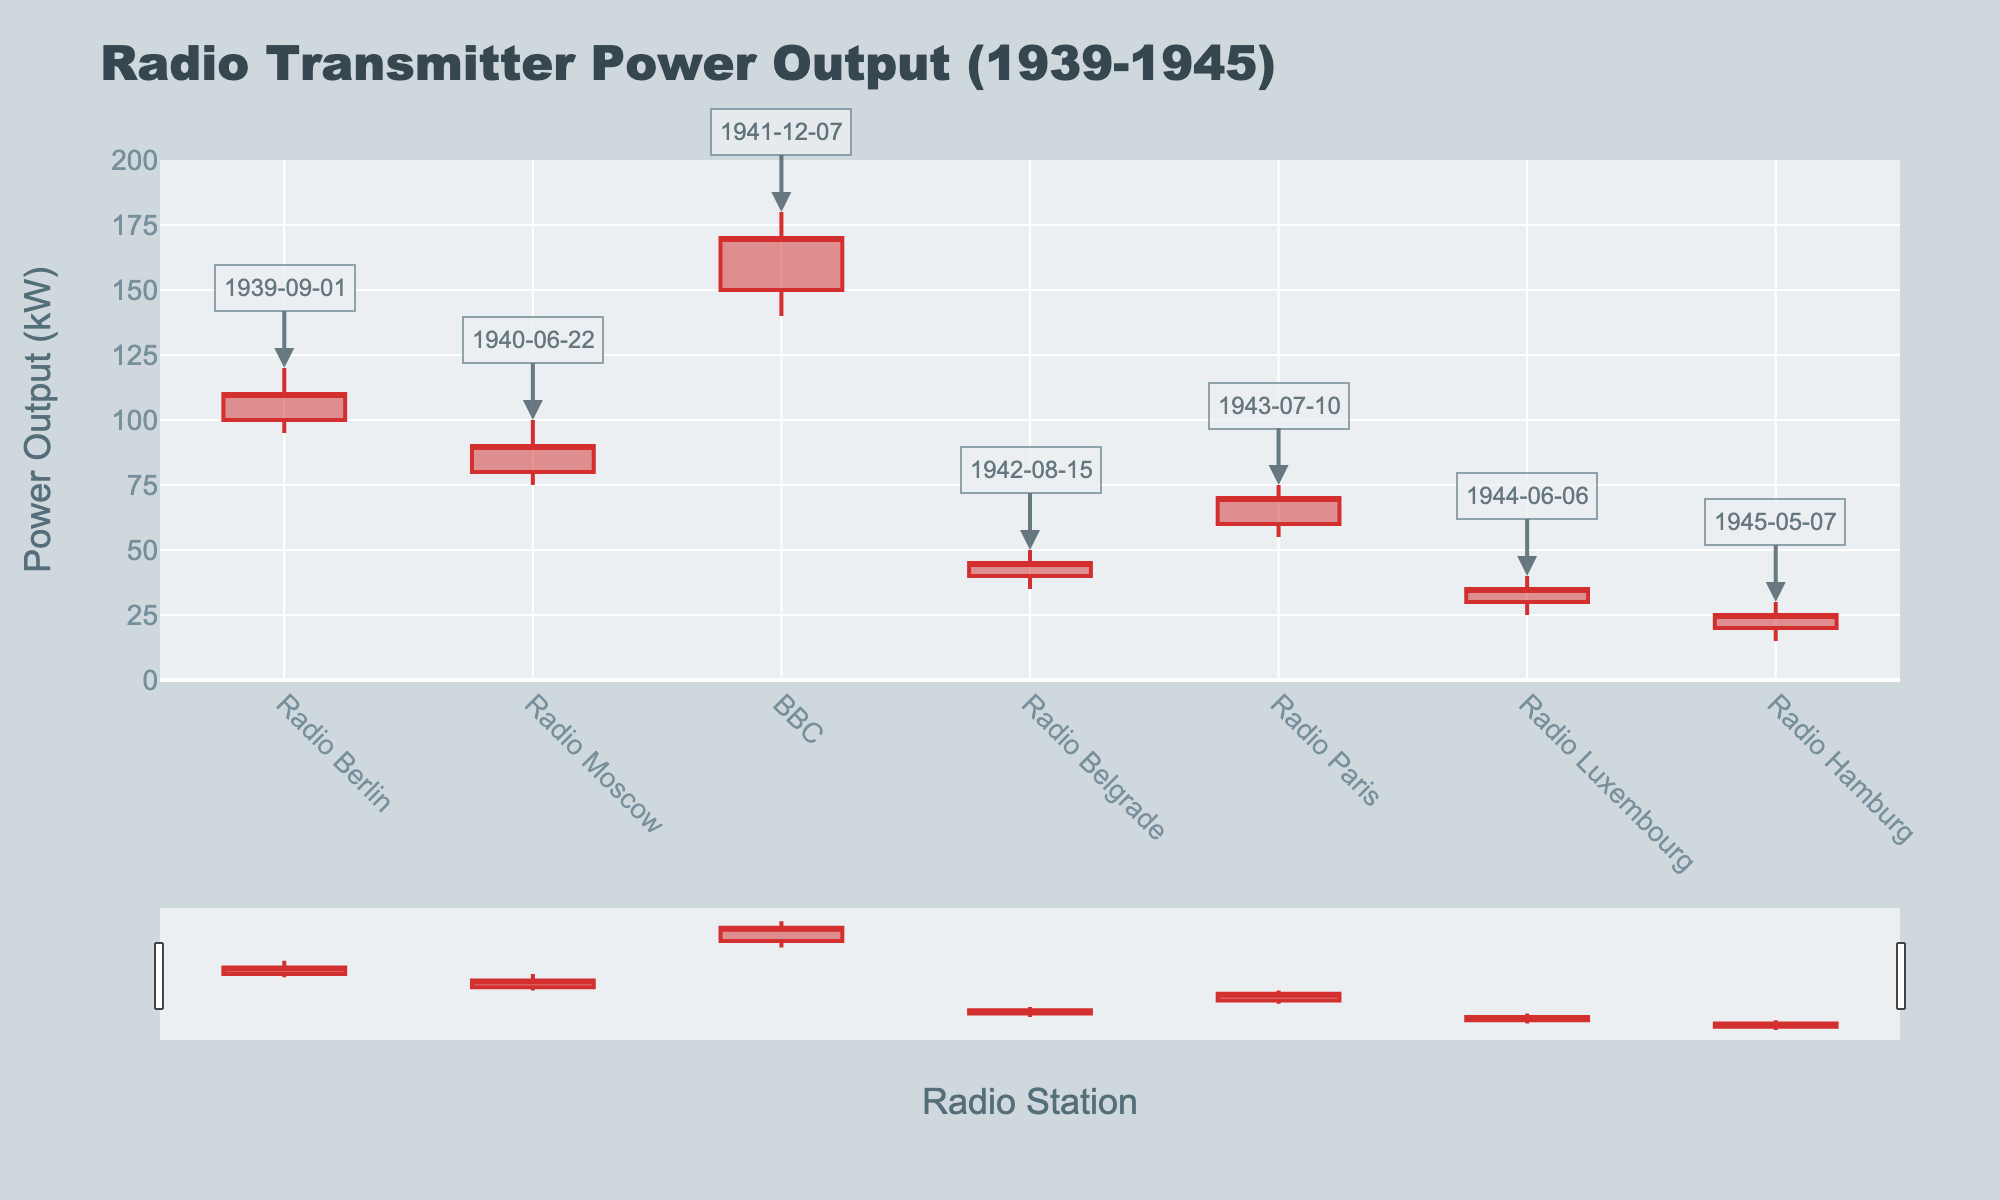What is the title of the figure? The title is located at the top of the figure and it reads 'Radio Transmitter Power Output (1939-1945)'.
Answer: Radio Transmitter Power Output (1939-1945) Which radio station has the highest 'High' value? The 'High' value can be checked for each station. The highest value observed is 180 kW for the BBC.
Answer: BBC What is the difference between the 'Open' and 'Close' values for Radio Belgrade? To find the difference, subtract the 'Close' value from the 'Open' value for Radio Belgrade, which is 40 - 45 = -5 kW.
Answer: -5 kW Which radio station experienced the lowest 'Low' value? By checking the 'Low' values across all radio stations, Radio Hamburg has the lowest value of 15 kW.
Answer: Radio Hamburg What is the average 'Open' value across all the radio stations? Calculate the average by summing the 'Open' values (100 + 80 + 150 + 40 + 60 + 30 + 20) and dividing by the number of stations (7), which is 480 / 7 ≈ 68.57 kW.
Answer: 68.57 kW Which date is annotated for Radio Luxembourg? The annotation for each station can be checked, and the date annotated for Radio Luxembourg is 1944-06-06.
Answer: 1944-06-06 How much did the 'Close' value for Radio Moscow increase from the 'Low' value? The increase can be determined by subtracting the 'Low' value from the 'Close' value for Radio Moscow, which is 90 - 75 = 15 kW.
Answer: 15 kW What is the median 'Close' value across all the stations? List the 'Close' values in ascending order: 25, 35, 45, 70, 90, 110, 170, with the median being the middle value, which is 70 kW.
Answer: 70 kW Which station had the smallest range between 'High' and 'Low' values? Calculate the range for each station (High - Low). The smallest range is for Radio Luxembourg (40 - 25 = 15 kW).
Answer: Radio Luxembourg How much higher is the 'Open' value for BBC compared to Radio Hamburg? Subtract the 'Open' value of Radio Hamburg from the BBC's 'Open' value, which is 150 - 20 = 130 kW.
Answer: 130 kW 